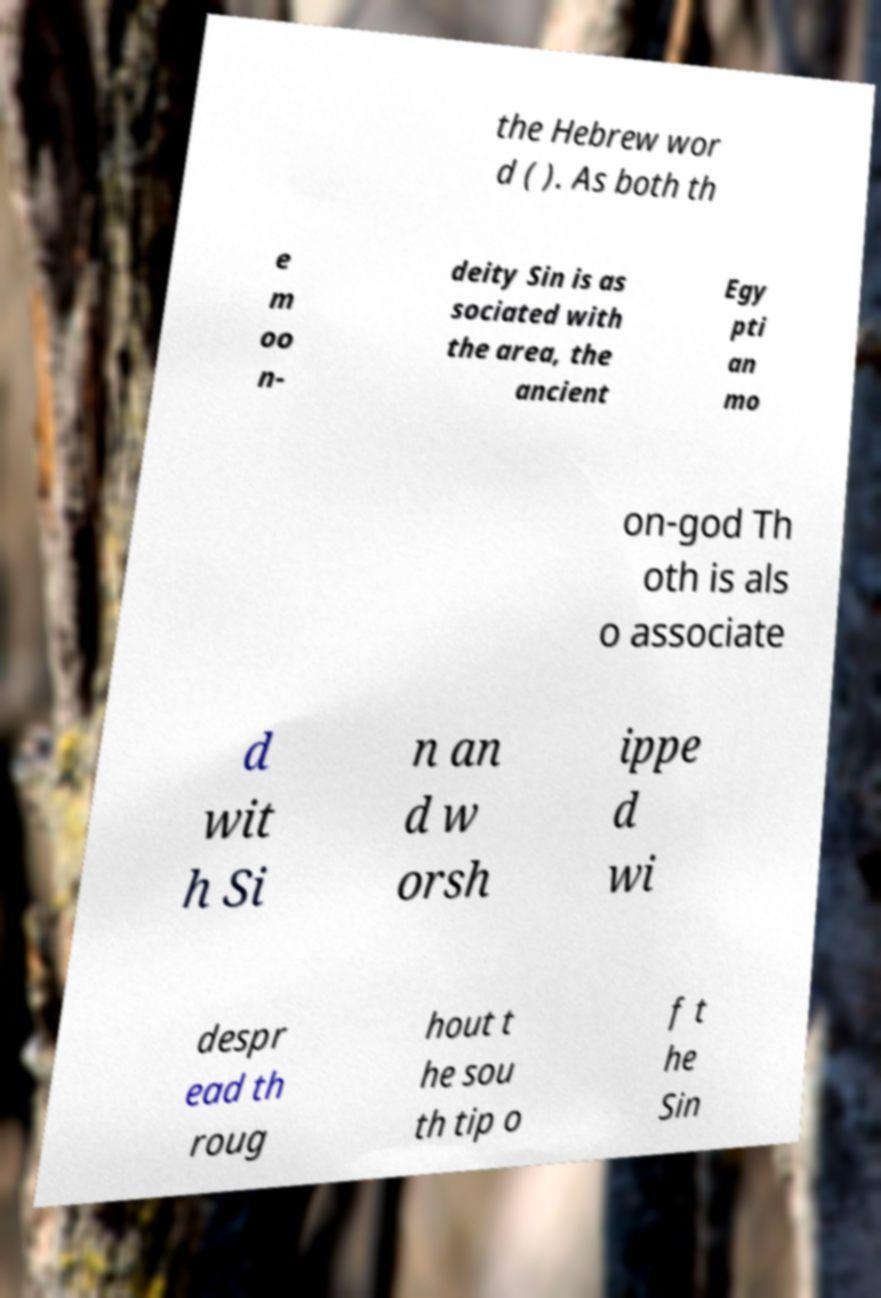Could you extract and type out the text from this image? the Hebrew wor d ( ). As both th e m oo n- deity Sin is as sociated with the area, the ancient Egy pti an mo on-god Th oth is als o associate d wit h Si n an d w orsh ippe d wi despr ead th roug hout t he sou th tip o f t he Sin 